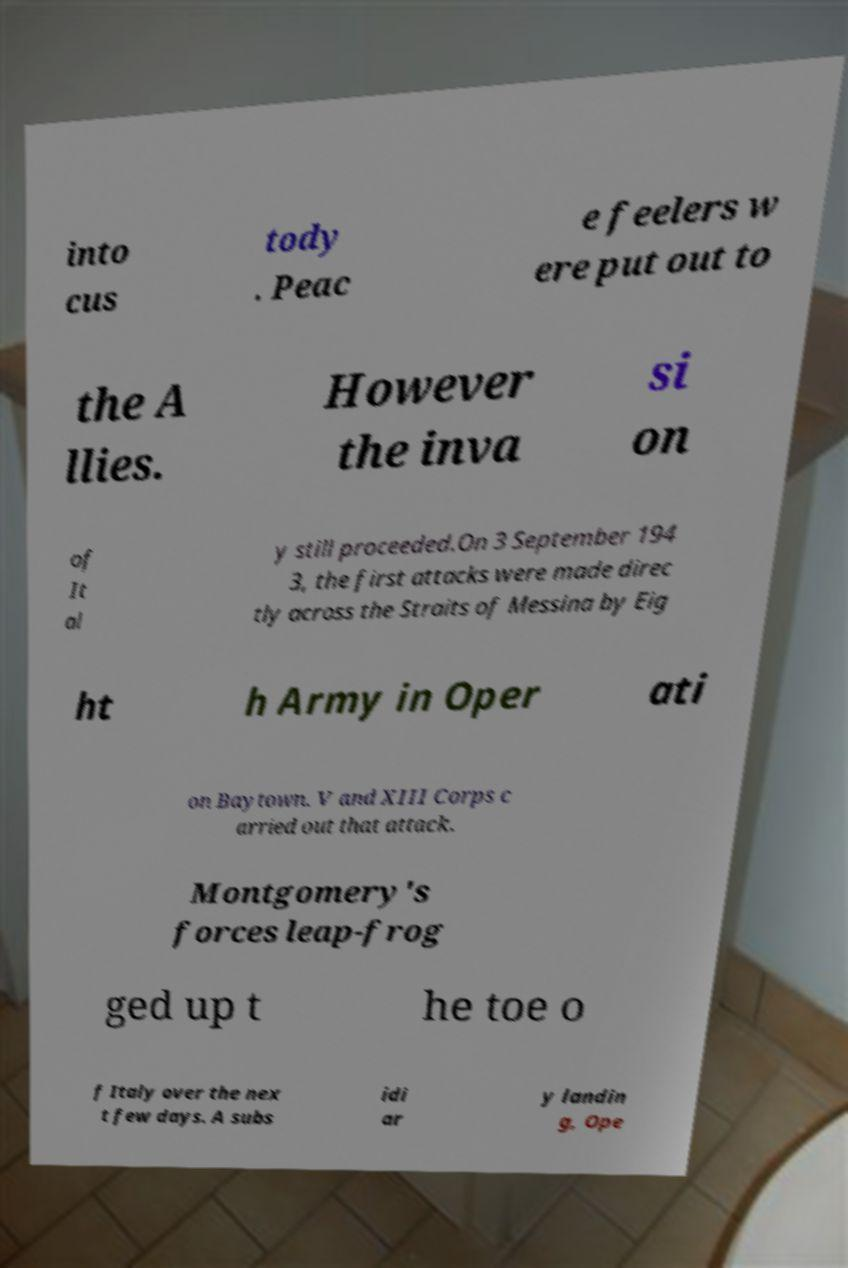What messages or text are displayed in this image? I need them in a readable, typed format. into cus tody . Peac e feelers w ere put out to the A llies. However the inva si on of It al y still proceeded.On 3 September 194 3, the first attacks were made direc tly across the Straits of Messina by Eig ht h Army in Oper ati on Baytown. V and XIII Corps c arried out that attack. Montgomery's forces leap-frog ged up t he toe o f Italy over the nex t few days. A subs idi ar y landin g, Ope 